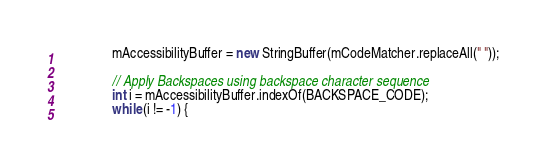Convert code to text. <code><loc_0><loc_0><loc_500><loc_500><_Java_>				mAccessibilityBuffer = new StringBuffer(mCodeMatcher.replaceAll(" "));

				// Apply Backspaces using backspace character sequence
				int i = mAccessibilityBuffer.indexOf(BACKSPACE_CODE);
				while (i != -1) {</code> 